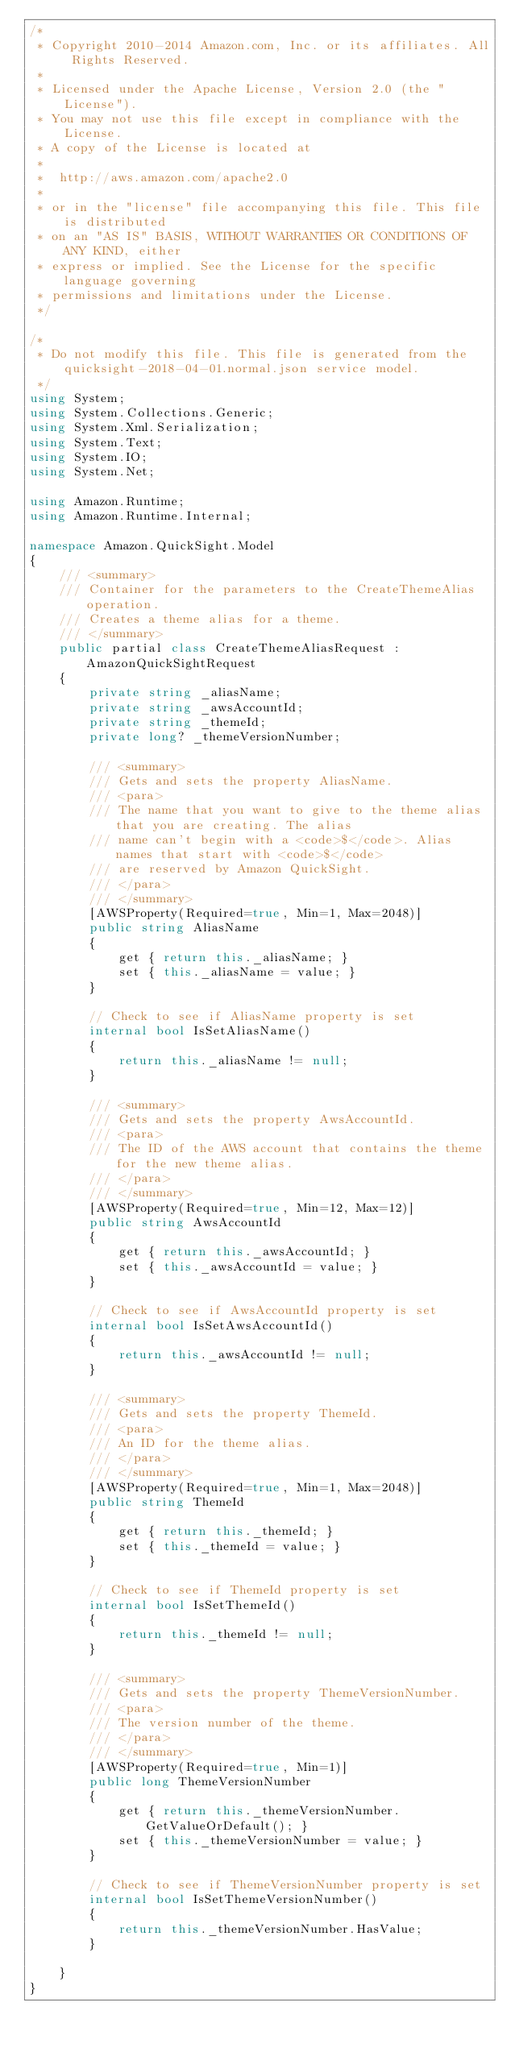Convert code to text. <code><loc_0><loc_0><loc_500><loc_500><_C#_>/*
 * Copyright 2010-2014 Amazon.com, Inc. or its affiliates. All Rights Reserved.
 * 
 * Licensed under the Apache License, Version 2.0 (the "License").
 * You may not use this file except in compliance with the License.
 * A copy of the License is located at
 * 
 *  http://aws.amazon.com/apache2.0
 * 
 * or in the "license" file accompanying this file. This file is distributed
 * on an "AS IS" BASIS, WITHOUT WARRANTIES OR CONDITIONS OF ANY KIND, either
 * express or implied. See the License for the specific language governing
 * permissions and limitations under the License.
 */

/*
 * Do not modify this file. This file is generated from the quicksight-2018-04-01.normal.json service model.
 */
using System;
using System.Collections.Generic;
using System.Xml.Serialization;
using System.Text;
using System.IO;
using System.Net;

using Amazon.Runtime;
using Amazon.Runtime.Internal;

namespace Amazon.QuickSight.Model
{
    /// <summary>
    /// Container for the parameters to the CreateThemeAlias operation.
    /// Creates a theme alias for a theme.
    /// </summary>
    public partial class CreateThemeAliasRequest : AmazonQuickSightRequest
    {
        private string _aliasName;
        private string _awsAccountId;
        private string _themeId;
        private long? _themeVersionNumber;

        /// <summary>
        /// Gets and sets the property AliasName. 
        /// <para>
        /// The name that you want to give to the theme alias that you are creating. The alias
        /// name can't begin with a <code>$</code>. Alias names that start with <code>$</code>
        /// are reserved by Amazon QuickSight. 
        /// </para>
        /// </summary>
        [AWSProperty(Required=true, Min=1, Max=2048)]
        public string AliasName
        {
            get { return this._aliasName; }
            set { this._aliasName = value; }
        }

        // Check to see if AliasName property is set
        internal bool IsSetAliasName()
        {
            return this._aliasName != null;
        }

        /// <summary>
        /// Gets and sets the property AwsAccountId. 
        /// <para>
        /// The ID of the AWS account that contains the theme for the new theme alias.
        /// </para>
        /// </summary>
        [AWSProperty(Required=true, Min=12, Max=12)]
        public string AwsAccountId
        {
            get { return this._awsAccountId; }
            set { this._awsAccountId = value; }
        }

        // Check to see if AwsAccountId property is set
        internal bool IsSetAwsAccountId()
        {
            return this._awsAccountId != null;
        }

        /// <summary>
        /// Gets and sets the property ThemeId. 
        /// <para>
        /// An ID for the theme alias.
        /// </para>
        /// </summary>
        [AWSProperty(Required=true, Min=1, Max=2048)]
        public string ThemeId
        {
            get { return this._themeId; }
            set { this._themeId = value; }
        }

        // Check to see if ThemeId property is set
        internal bool IsSetThemeId()
        {
            return this._themeId != null;
        }

        /// <summary>
        /// Gets and sets the property ThemeVersionNumber. 
        /// <para>
        /// The version number of the theme.
        /// </para>
        /// </summary>
        [AWSProperty(Required=true, Min=1)]
        public long ThemeVersionNumber
        {
            get { return this._themeVersionNumber.GetValueOrDefault(); }
            set { this._themeVersionNumber = value; }
        }

        // Check to see if ThemeVersionNumber property is set
        internal bool IsSetThemeVersionNumber()
        {
            return this._themeVersionNumber.HasValue; 
        }

    }
}</code> 